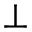Convert formula to latex. <formula><loc_0><loc_0><loc_500><loc_500>\perp</formula> 